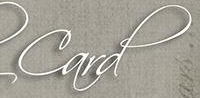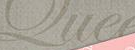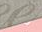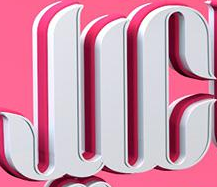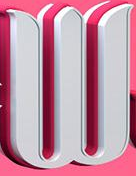Transcribe the words shown in these images in order, separated by a semicolon. Card; Que; #; JIC; W 